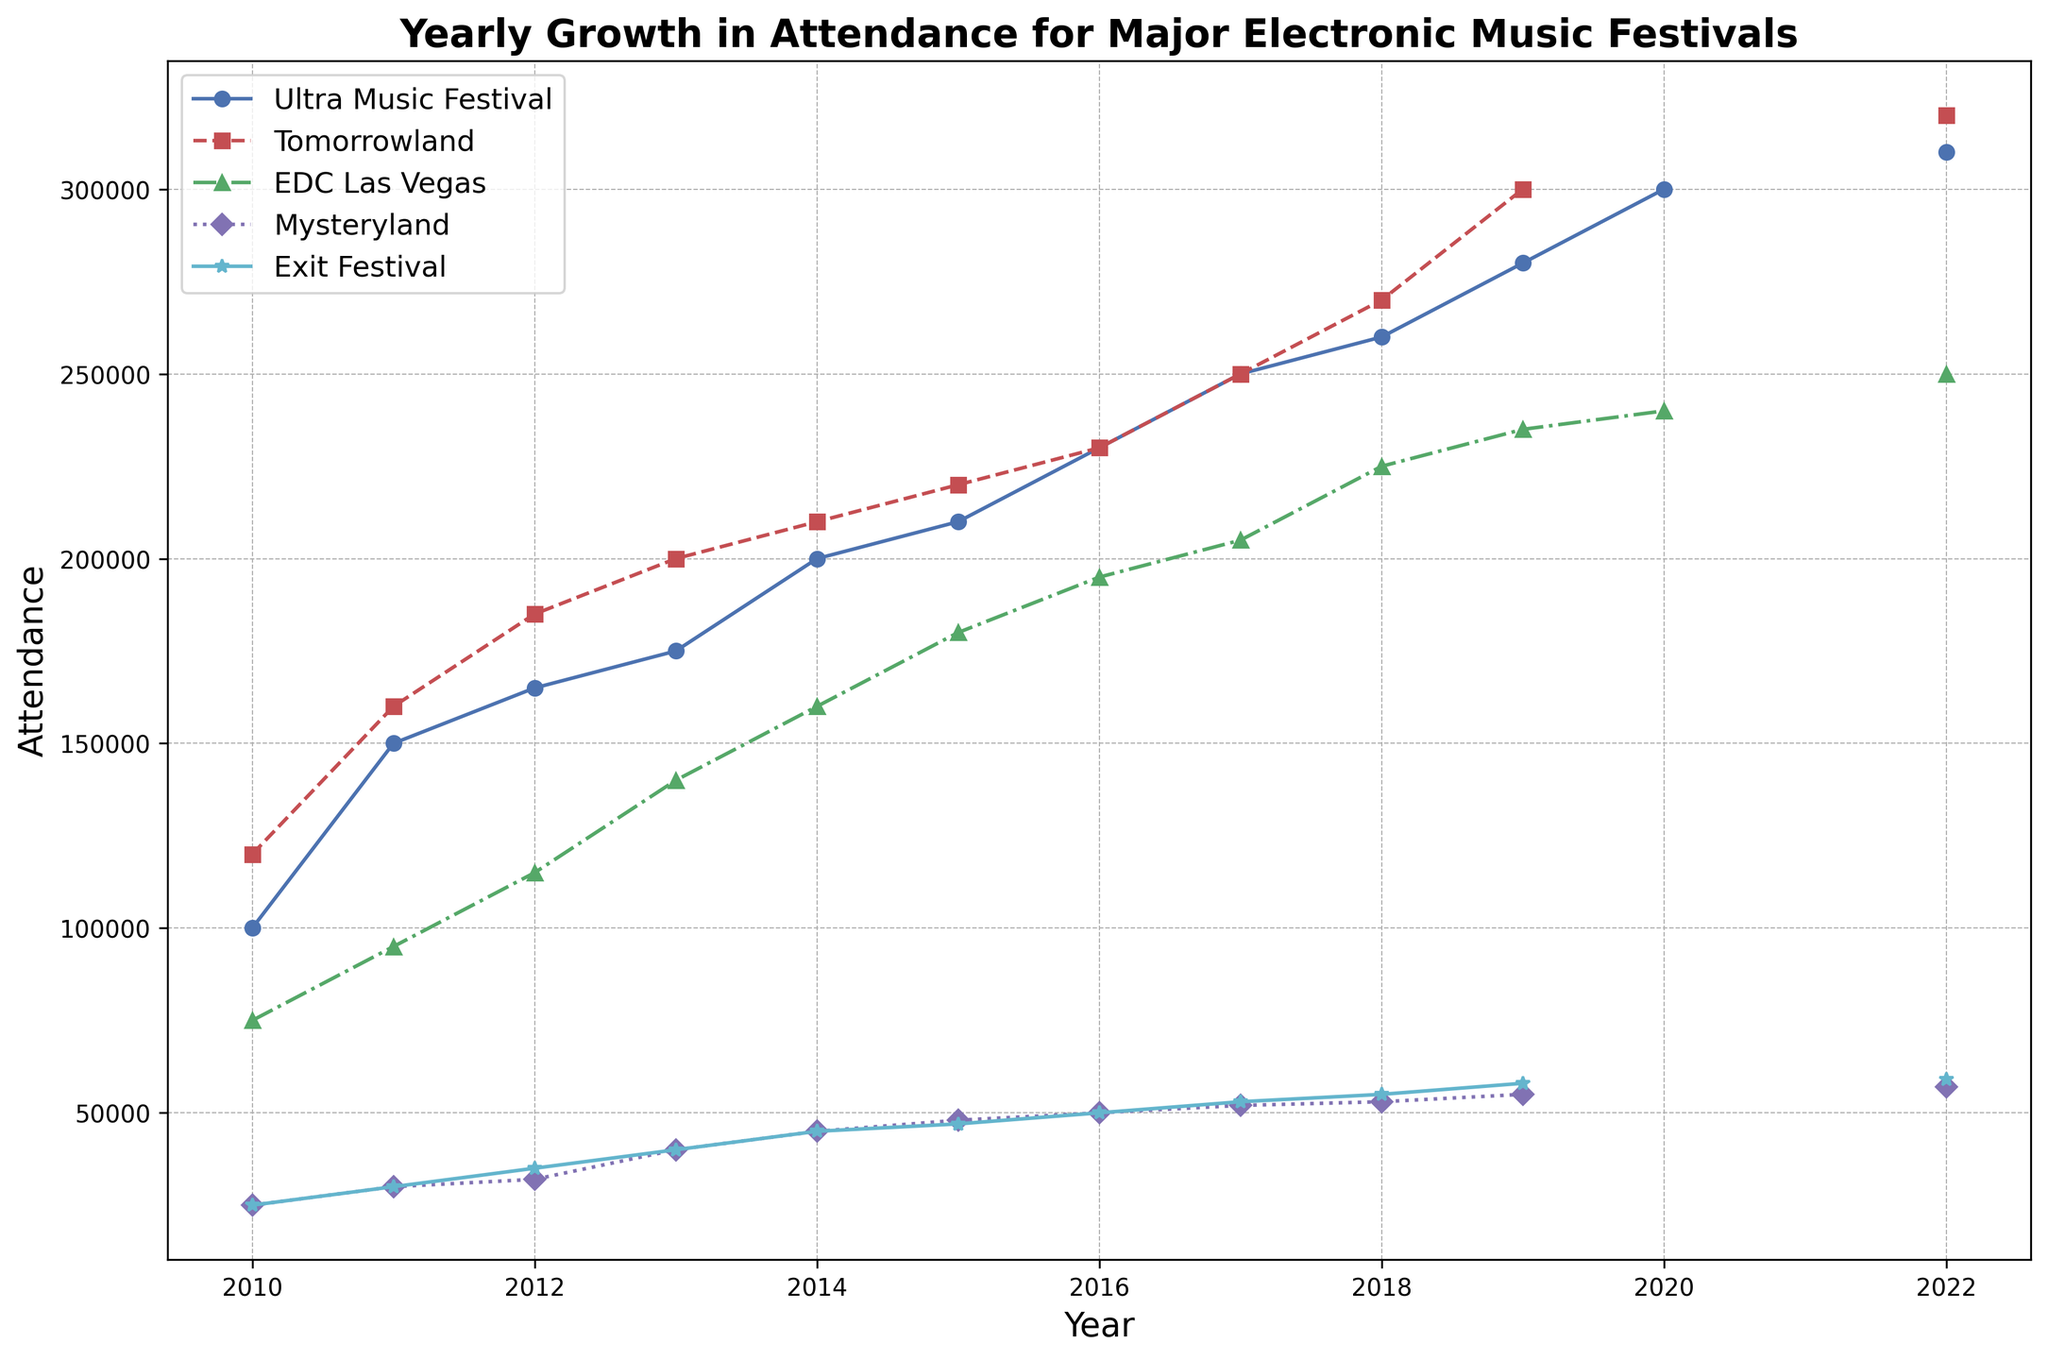What's the general trend in the attendance of Ultra Music Festival from 2010 to 2022? Observing the plot for Ultra Music Festival, the number of attendees generally shows a consistent upward trend, increasing from 100,000 in 2010 to 310,000 in 2022.
Answer: Increasing In which year did Tomorrowland see its highest attendance based on the figure? Looking at the plot for Tomorrowland, the highest attendance noted is in 2022, with 320,000 attendees.
Answer: 2022 Which festival had the smallest attendance in 2010, based on the plot? By comparing the different lines for the year 2010, Mysteryland and Exit Festival both had the smallest attendance of 25,000.
Answer: Mysteryland and Exit Festival What was the difference in attendance between EDC Las Vegas and Tomorrowland in 2013? In 2013, EDC Las Vegas had an attendance of 140,000, while Tomorrowland had 200,000. The difference is calculated as 200,000 - 140,000 = 60,000.
Answer: 60,000 Between Ultra Music Festival and EDC Las Vegas, which festival saw a larger average yearly increase in attendance from 2010 to 2022? (Exclude years with missing data) To find the average yearly increase: for Ultra Music Festival, the increase from 2010 to 2022 is 310,000 - 100,000 = 210,000 over 11 years, thus 210,000 / 11 ≈ 19,091 attendees per year. For EDC Las Vegas, the increase from 2010 to 2022 is 250,000 - 75,000 = 175,000 over 10 years (2010 to 2020), thus 175,000 / 10 = 17,500 attendees per year. Ultra Music Festival had a larger average yearly increase.
Answer: Ultra Music Festival Which two festivals had the closest attendance figures in 2018? In 2018, the plot lines for all festivals should be checked: Tomorrowland had 270,000 and Ultra Music Festival had 260,000. These two numbers are closest to each other, with a difference of 10,000.
Answer: Tomorrowland and Ultra Music Festival How did the attendance for Exit Festival change from 2012 to 2019? The attendance for Exit Festival was 35,000 in 2012 and increased to 58,000 in 2019. The change is an increase of 58,000 - 35,000 = 23,000.
Answer: Increase by 23,000 Which festival saw an attendance decline between any two consecutive years, and when did it occur? Observing all lines for any declines: EDC Las Vegas saw a decline between 2019 (235,000) and 2020 (240,000), showing an increase instead. There isn't a clear instance of decline for this data.
Answer: No clear decline What's the total attendance for the five festivals in 2012? Sum the attendee numbers for all five festivals in 2012: Ultra Music Festival (165,000) + Tomorrowland (185,000) + EDC Las Vegas (115,000) + Mysteryland (32,000) + Exit Festival (35,000) = 532,000.
Answer: 532,000 Which festival rebounded to its highest attendance in 2022 after having a year with missing data? Ultra Music Festival, Tomorrowland, and EDC Las Vegas had missing data in 2021 and rebounded in 2022. Tomorrowland specifically rebounded to its highest with 320,000 attendees.
Answer: Tomorrowland 